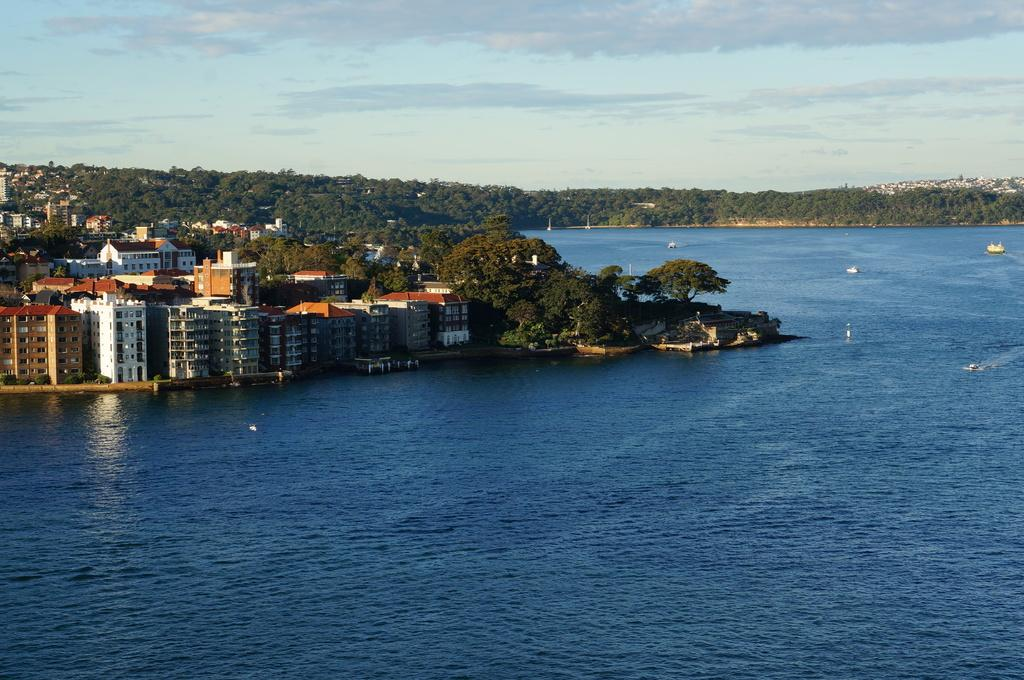What is located above the water in the image? There are boats above the water in the image. What type of natural vegetation can be seen in the image? Trees arees are visible in the image. What type of man-made structures are present in the image? Buildings are present in the image. What is visible in the background of the image? The sky is visible in the background of the image. What time is displayed on the clock in the image? There is no clock present in the image. What degree of difficulty is associated with the control panel in the image? There is no control panel present in the image. 